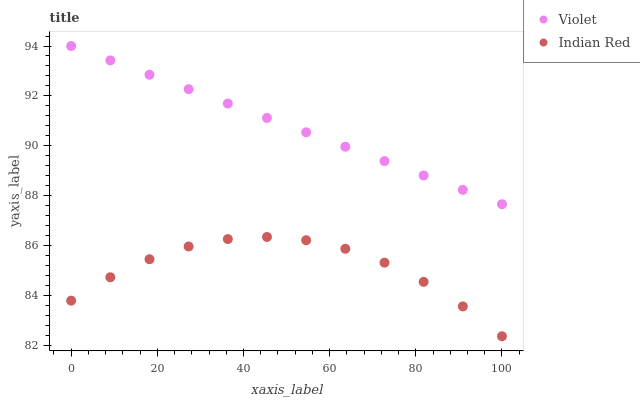Does Indian Red have the minimum area under the curve?
Answer yes or no. Yes. Does Violet have the maximum area under the curve?
Answer yes or no. Yes. Does Violet have the minimum area under the curve?
Answer yes or no. No. Is Violet the smoothest?
Answer yes or no. Yes. Is Indian Red the roughest?
Answer yes or no. Yes. Is Violet the roughest?
Answer yes or no. No. Does Indian Red have the lowest value?
Answer yes or no. Yes. Does Violet have the lowest value?
Answer yes or no. No. Does Violet have the highest value?
Answer yes or no. Yes. Is Indian Red less than Violet?
Answer yes or no. Yes. Is Violet greater than Indian Red?
Answer yes or no. Yes. Does Indian Red intersect Violet?
Answer yes or no. No. 